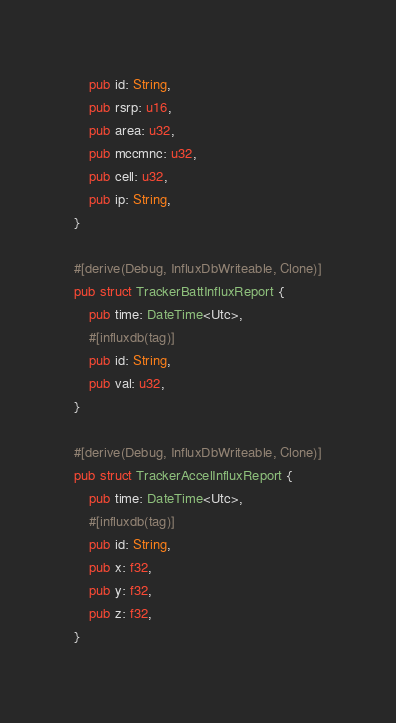<code> <loc_0><loc_0><loc_500><loc_500><_Rust_>    pub id: String,
    pub rsrp: u16,
    pub area: u32,
    pub mccmnc: u32,
    pub cell: u32,
    pub ip: String,
}

#[derive(Debug, InfluxDbWriteable, Clone)]
pub struct TrackerBattInfluxReport {
    pub time: DateTime<Utc>,
    #[influxdb(tag)]
    pub id: String,
    pub val: u32,
}

#[derive(Debug, InfluxDbWriteable, Clone)]
pub struct TrackerAccelInfluxReport {
    pub time: DateTime<Utc>,
    #[influxdb(tag)]
    pub id: String,
    pub x: f32,
    pub y: f32,
    pub z: f32,
}
</code> 